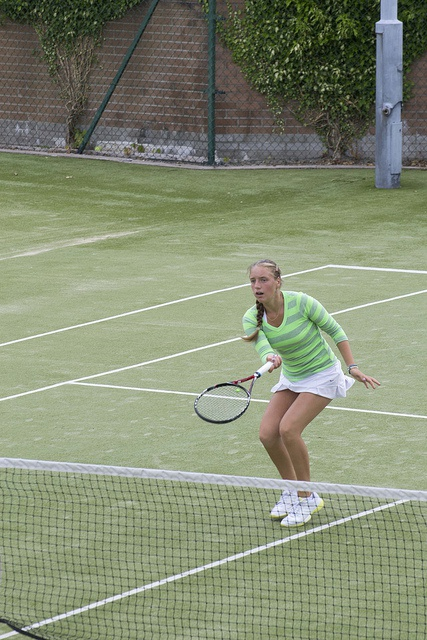Describe the objects in this image and their specific colors. I can see people in darkgreen, darkgray, lightgray, and gray tones and tennis racket in darkgreen, darkgray, lightgray, and gray tones in this image. 